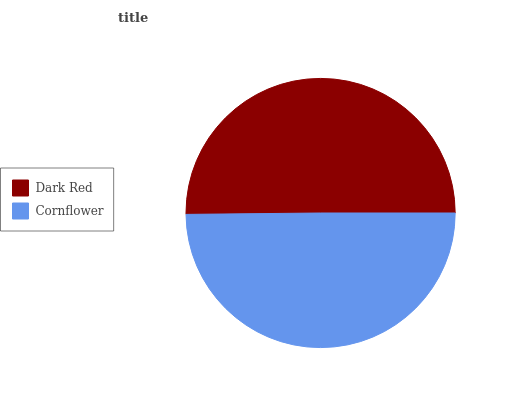Is Cornflower the minimum?
Answer yes or no. Yes. Is Dark Red the maximum?
Answer yes or no. Yes. Is Cornflower the maximum?
Answer yes or no. No. Is Dark Red greater than Cornflower?
Answer yes or no. Yes. Is Cornflower less than Dark Red?
Answer yes or no. Yes. Is Cornflower greater than Dark Red?
Answer yes or no. No. Is Dark Red less than Cornflower?
Answer yes or no. No. Is Dark Red the high median?
Answer yes or no. Yes. Is Cornflower the low median?
Answer yes or no. Yes. Is Cornflower the high median?
Answer yes or no. No. Is Dark Red the low median?
Answer yes or no. No. 